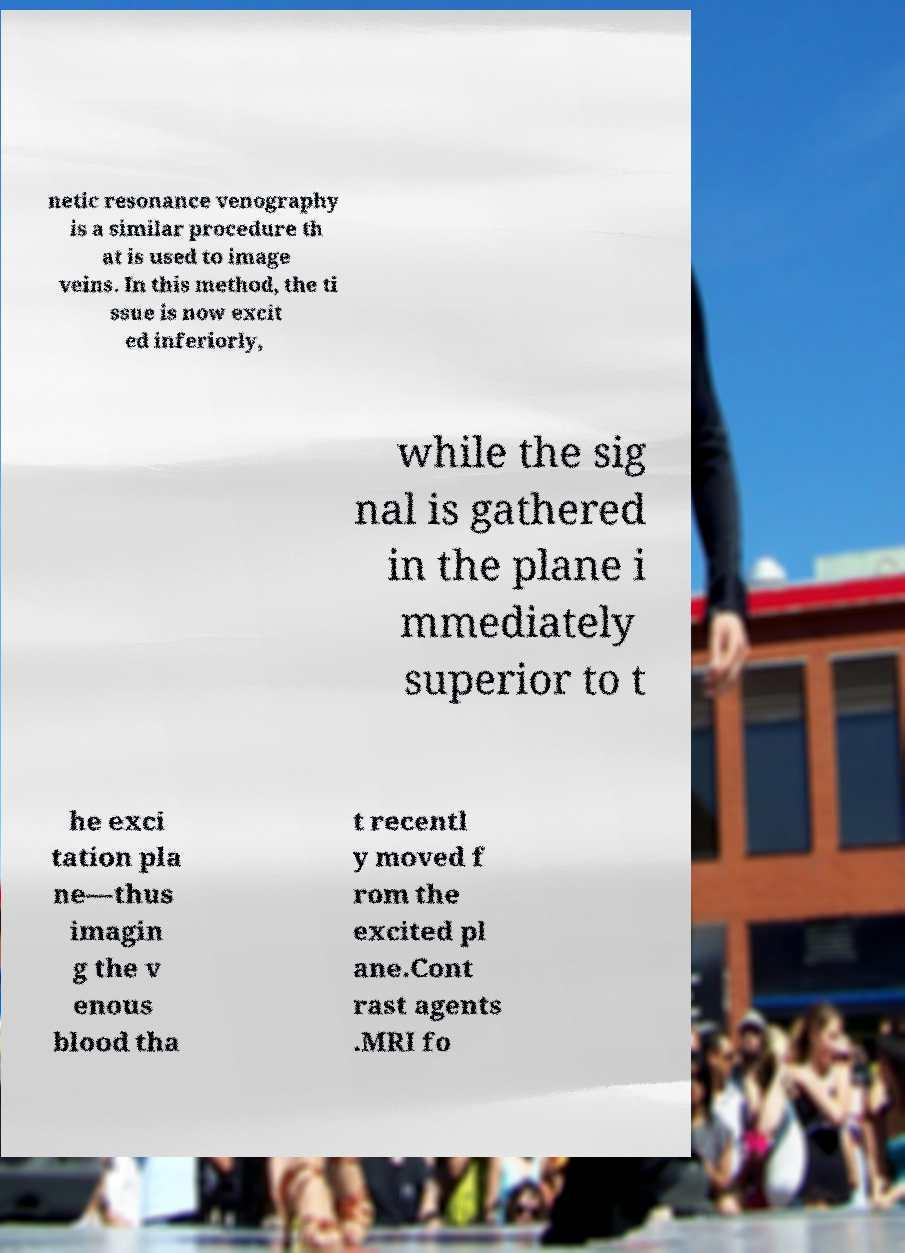Can you accurately transcribe the text from the provided image for me? netic resonance venography is a similar procedure th at is used to image veins. In this method, the ti ssue is now excit ed inferiorly, while the sig nal is gathered in the plane i mmediately superior to t he exci tation pla ne—thus imagin g the v enous blood tha t recentl y moved f rom the excited pl ane.Cont rast agents .MRI fo 